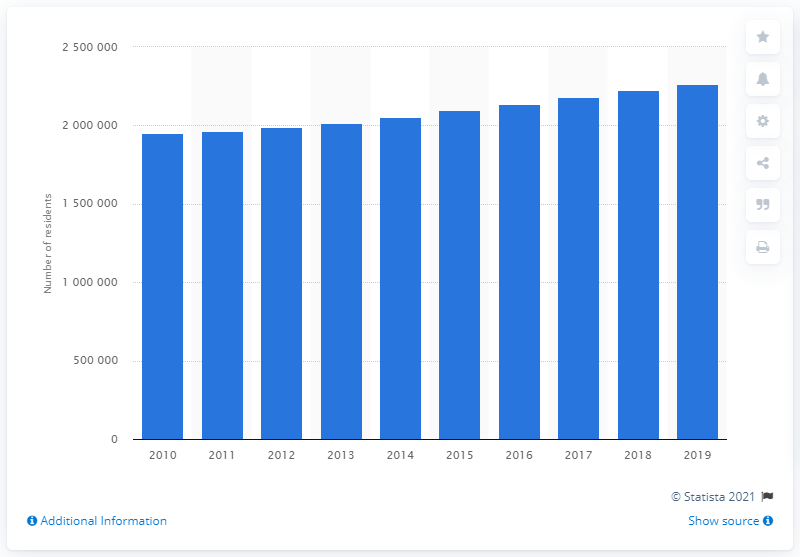Indicate a few pertinent items in this graphic. In 2019, the population of the Las Vegas-Henderson-Paradise metropolitan area was approximately 2,266,715 people. 